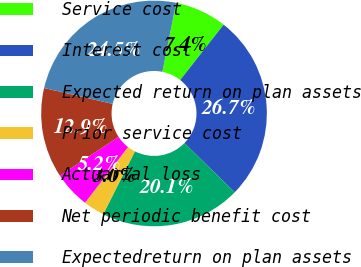Convert chart. <chart><loc_0><loc_0><loc_500><loc_500><pie_chart><fcel>Service cost<fcel>Interest cost<fcel>Expected return on plan assets<fcel>Prior service cost<fcel>Actuarial loss<fcel>Net periodic benefit cost<fcel>Expectedreturn on plan assets<nl><fcel>7.44%<fcel>26.73%<fcel>20.12%<fcel>3.04%<fcel>5.24%<fcel>12.91%<fcel>24.53%<nl></chart> 